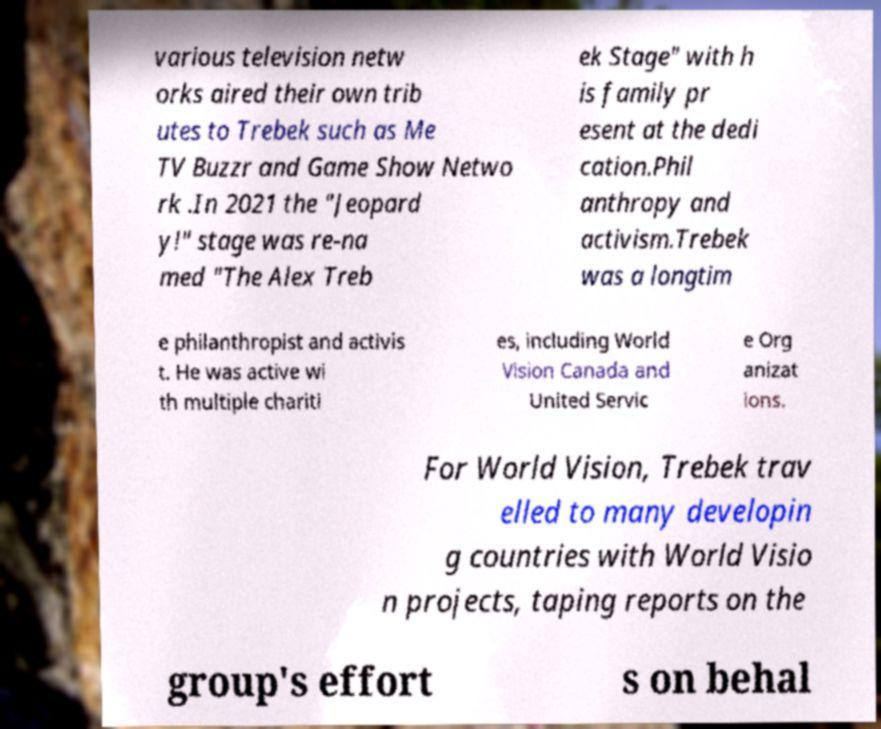Please identify and transcribe the text found in this image. various television netw orks aired their own trib utes to Trebek such as Me TV Buzzr and Game Show Netwo rk .In 2021 the "Jeopard y!" stage was re-na med "The Alex Treb ek Stage" with h is family pr esent at the dedi cation.Phil anthropy and activism.Trebek was a longtim e philanthropist and activis t. He was active wi th multiple chariti es, including World Vision Canada and United Servic e Org anizat ions. For World Vision, Trebek trav elled to many developin g countries with World Visio n projects, taping reports on the group's effort s on behal 